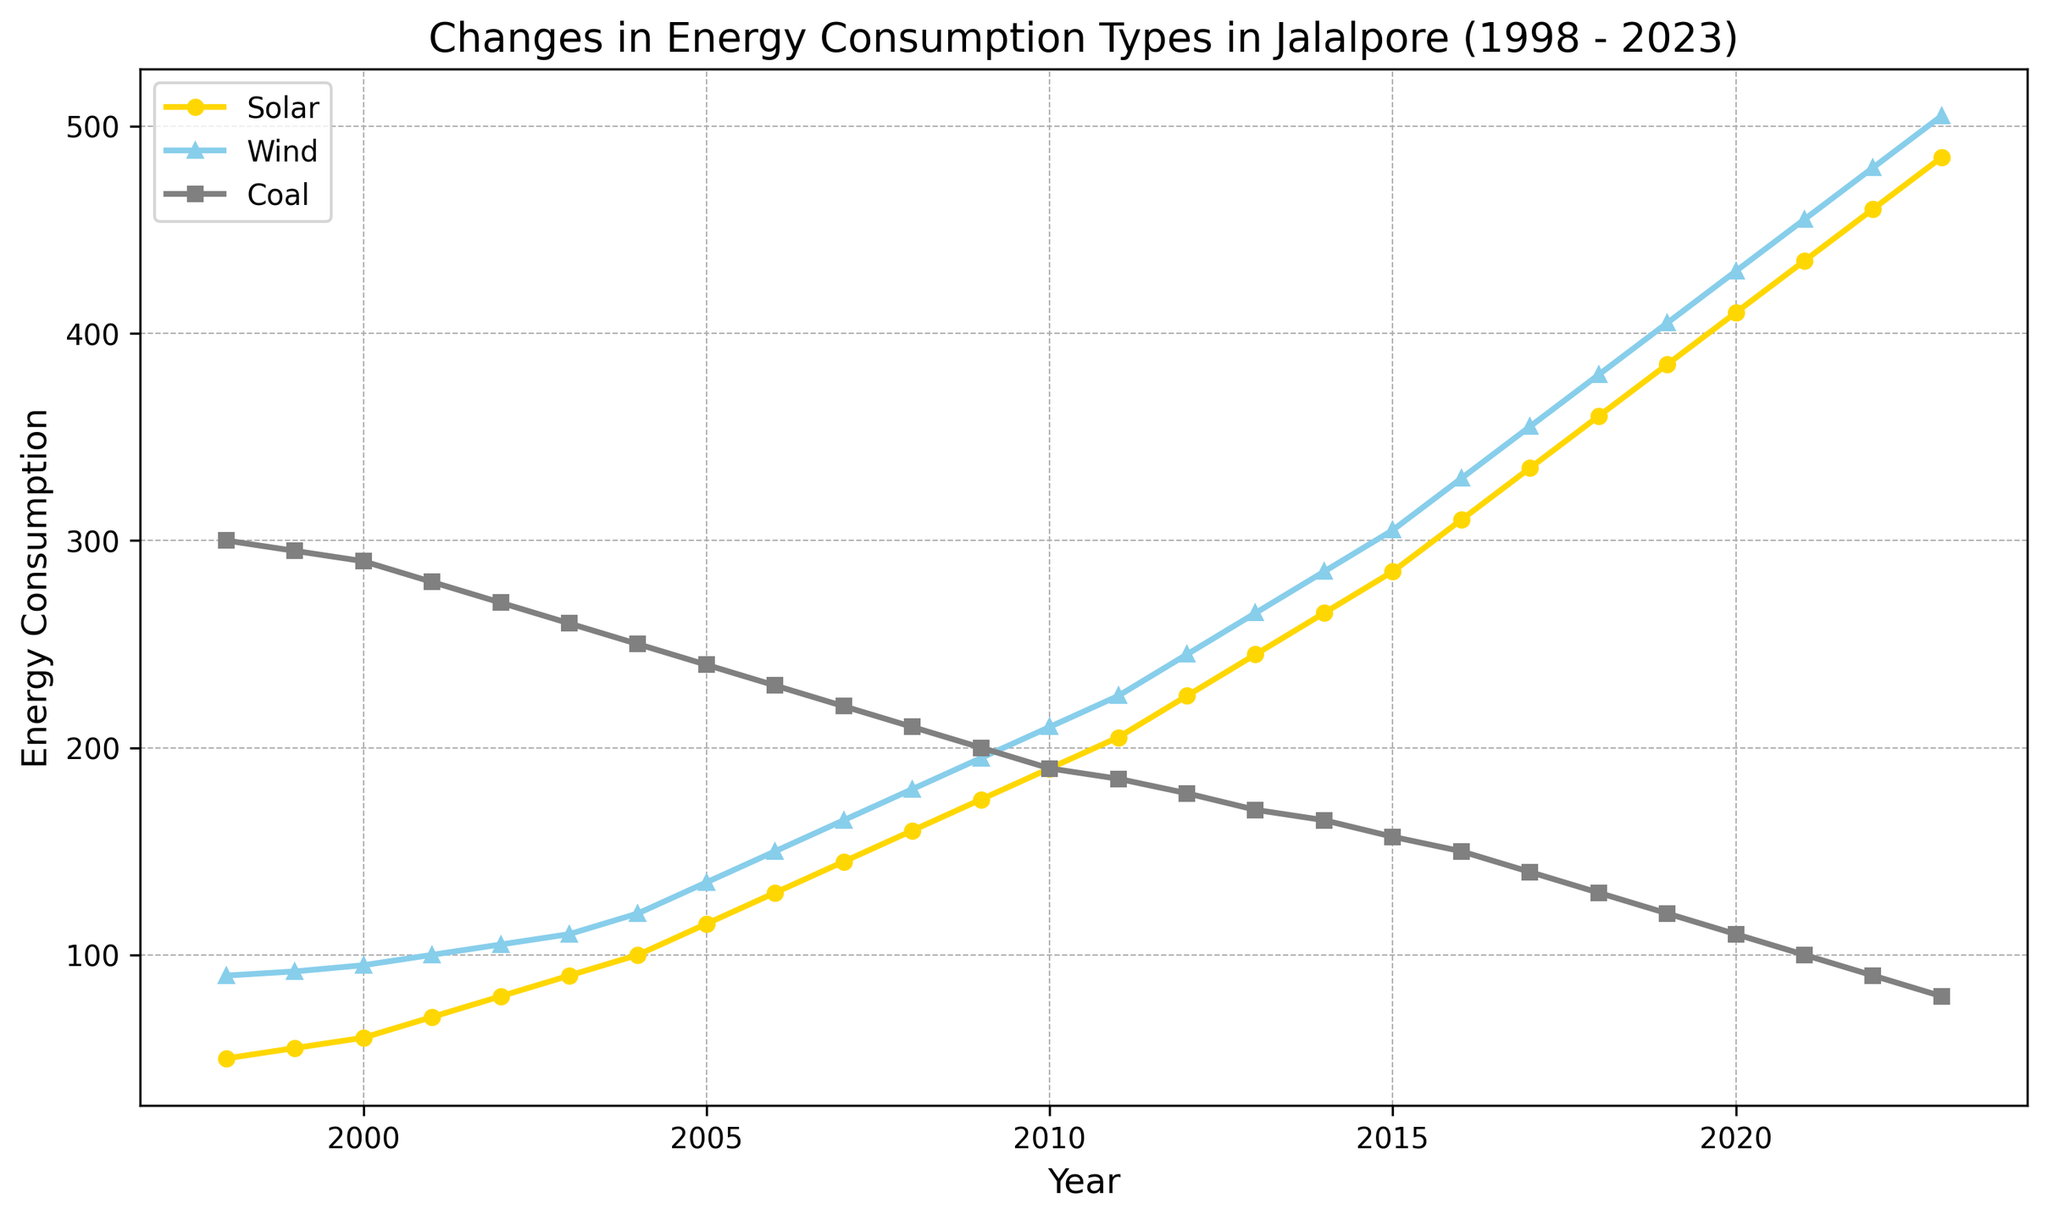What year saw the highest solar energy consumption? The visual shows that the solar energy consumption increases over time and is highest in the last year (2023).
Answer: 2023 Compare the coal and wind energy consumption in 2010. Which one was higher? The visual shows coal energy consumption at 190 in 2010 and wind energy consumption at 210. Therefore, wind consumption is higher.
Answer: Wind By how much did solar energy consumption increase between 1998 and 2023? In 1998, solar energy consumption was 50, and in 2023, it was 485. The increase is 485 - 50 = 435.
Answer: 435 What is the average coal energy consumption over the 25-year period? Sum the coal consumption values from 1998 to 2023 and divide by 26 (the number of years). (300 + 295 + ... + 80)/26 = 185.38
Answer: 185.38 In which year did wind energy consumption surpass 400 for the first time? The visual shows that wind energy consumption surpasses 400 in the year 2019.
Answer: 2019 How did the trend in coal energy consumption compare to solar and wind energy consumption from 1998 to 2023? The visual shows a declining trend for coal, while solar and wind energy consumption have increasing trends over this period.
Answer: Decline vs. Increase Which year had equal or near-equal consumption for solar and wind energy? The visual shows that in the year 1998, wind energy consumption was 90, and solar consumption was 50. They do not come near equality throughout the entire period.
Answer: Never During which years did coal consumption decrease the most significantly? The visual shows a steady decline in coal consumption, but the most significant annual drop occurs between 1999 and 2000, and between 1998 and 1999 where it drops by 5 units from 295 to 290.
Answer: 1999-2000 & 1998-1999 Between 2008 and 2012, which type of energy saw the highest increase in consumption? The visual shows that between 2008 and 2012, solar increased from 160 to 225 (65 units), wind from 180 to 245 (65 units), and coal decreased. Both solar and wind saw equal increments.
Answer: Solar & Wind 